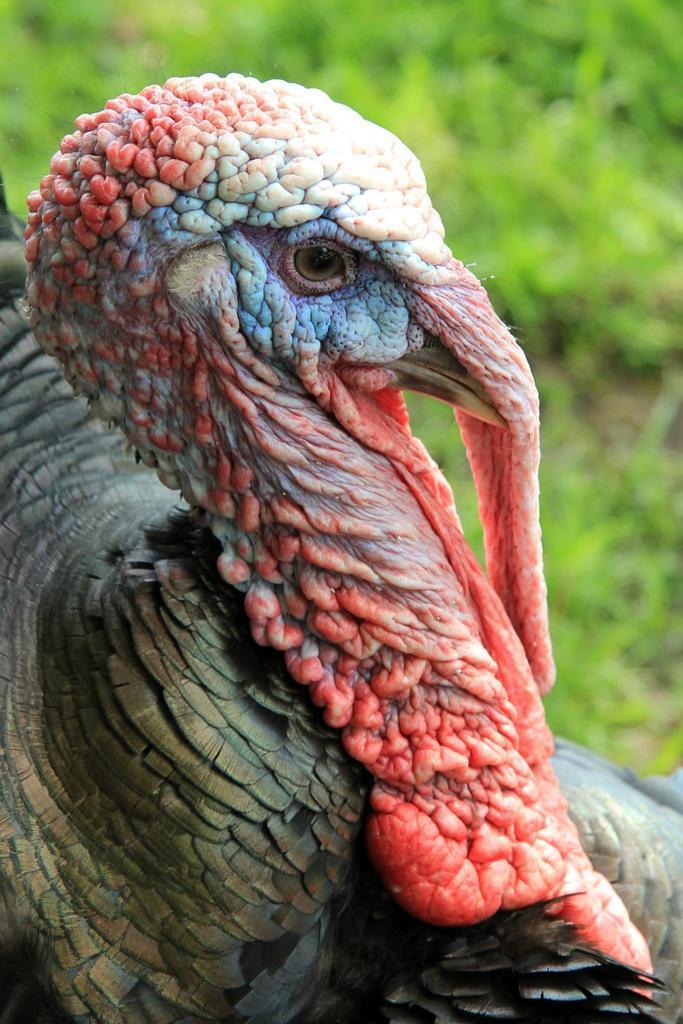How would you summarize this image in a sentence or two? In this image we can see a bird. 